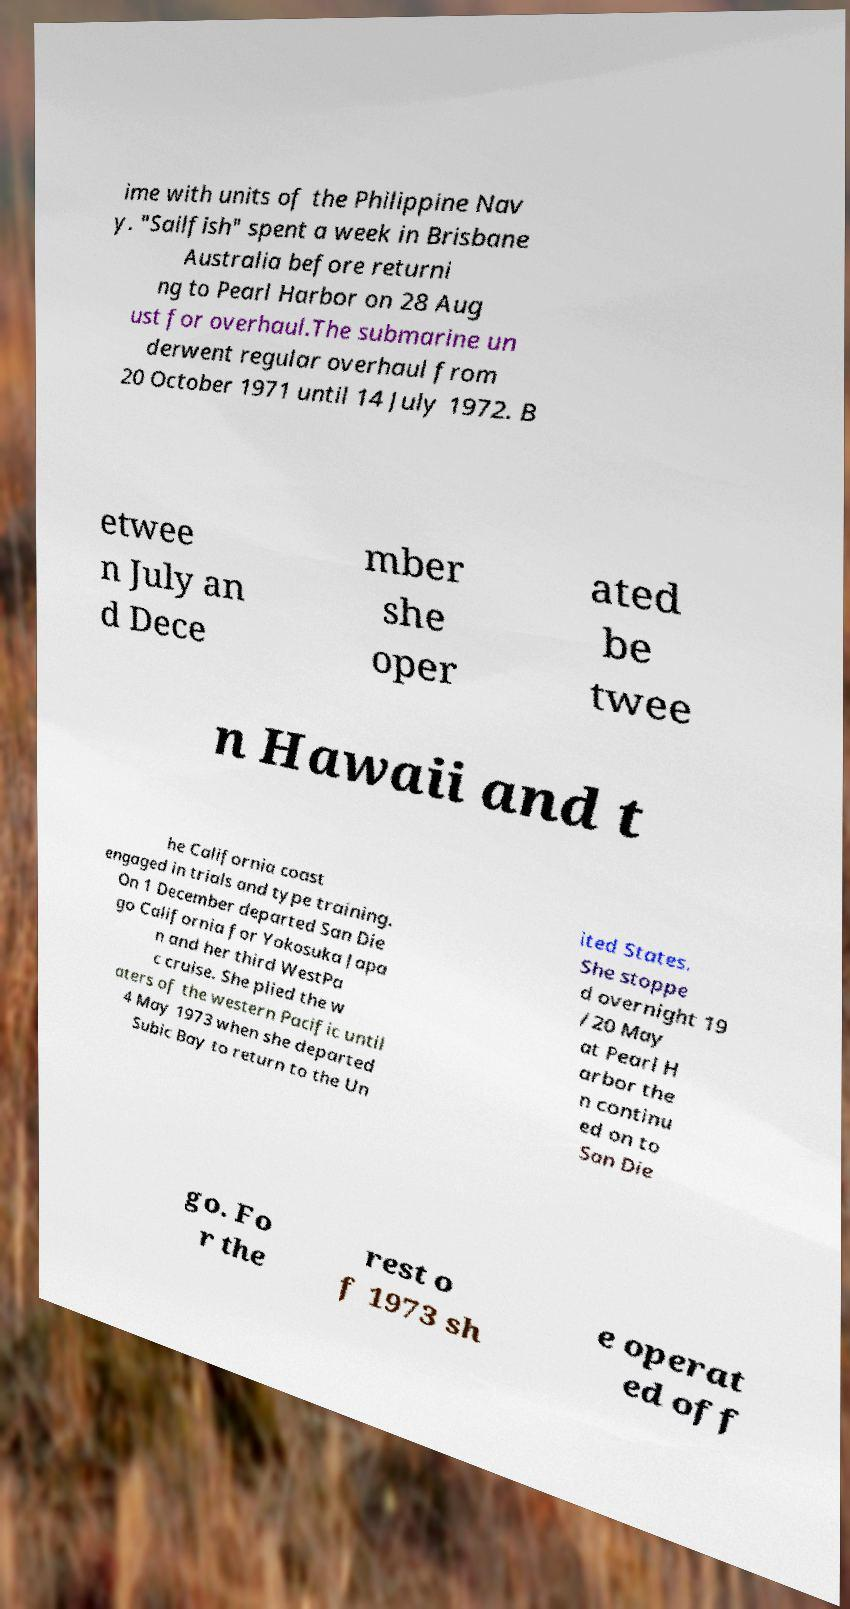Please identify and transcribe the text found in this image. ime with units of the Philippine Nav y. "Sailfish" spent a week in Brisbane Australia before returni ng to Pearl Harbor on 28 Aug ust for overhaul.The submarine un derwent regular overhaul from 20 October 1971 until 14 July 1972. B etwee n July an d Dece mber she oper ated be twee n Hawaii and t he California coast engaged in trials and type training. On 1 December departed San Die go California for Yokosuka Japa n and her third WestPa c cruise. She plied the w aters of the western Pacific until 4 May 1973 when she departed Subic Bay to return to the Un ited States. She stoppe d overnight 19 /20 May at Pearl H arbor the n continu ed on to San Die go. Fo r the rest o f 1973 sh e operat ed off 